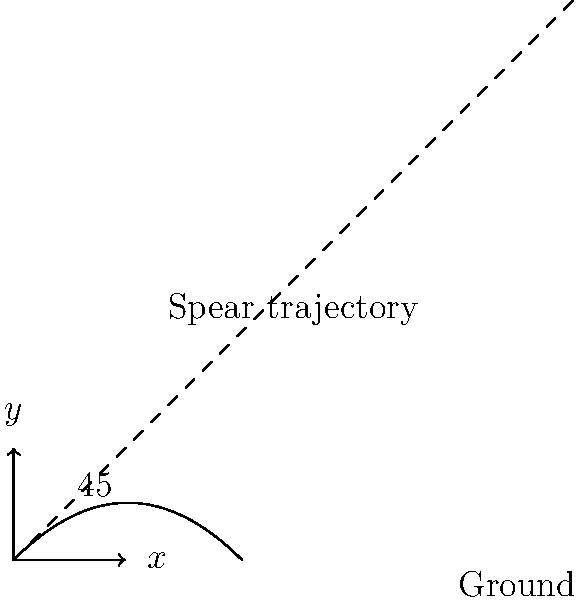When throwing a spear for maximum distance, which angle should be used relative to the horizontal ground? To determine the optimal angle for throwing a spear to achieve maximum distance, we need to consider the principles of projectile motion:

1. The motion of the spear can be described using two components: horizontal and vertical.

2. The horizontal motion is constant (neglecting air resistance), while the vertical motion is affected by gravity.

3. The distance traveled by the spear (range) is given by the equation:

   $$R = \frac{v_0^2 \sin(2\theta)}{g}$$

   Where:
   $R$ is the range
   $v_0$ is the initial velocity
   $\theta$ is the angle of launch
   $g$ is the acceleration due to gravity

4. To find the maximum range, we need to maximize $\sin(2\theta)$.

5. The maximum value of sine function is 1, which occurs when its argument is 90°.

6. Therefore, $2\theta = 90°$ or $\theta = 45°$.

7. This result is independent of the initial velocity and the acceleration due to gravity, making it universally applicable (in ideal conditions).

In practice, factors like air resistance and the aerodynamics of the spear might slightly alter this angle, but 45° remains a good approximation for maximum distance in most scenarios.
Answer: 45° 